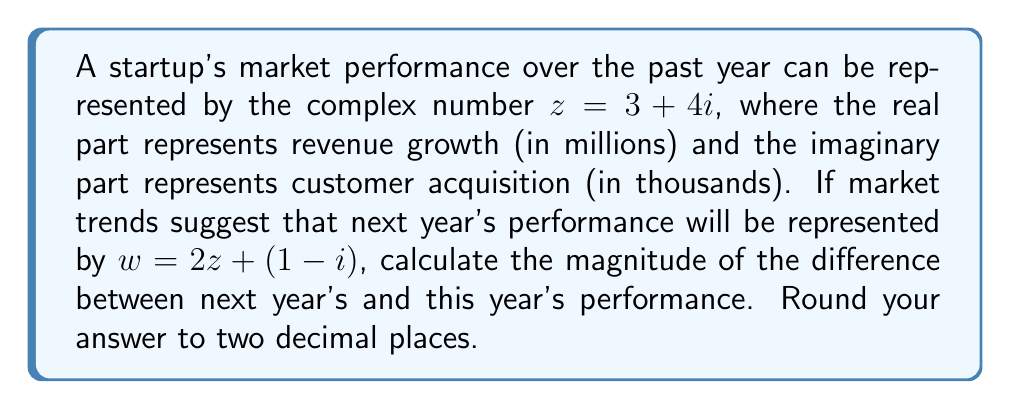Could you help me with this problem? Let's approach this step-by-step:

1) First, we need to calculate $w$:
   $w = 2z + (1-i)$
   $w = 2(3+4i) + (1-i)$
   $w = 6 + 8i + 1 - i$
   $w = 7 + 7i$

2) Now, we need to find the difference between $w$ and $z$:
   $w - z = (7 + 7i) - (3 + 4i)$
   $w - z = 4 + 3i$

3) To find the magnitude of this difference, we use the formula:
   $|a + bi| = \sqrt{a^2 + b^2}$

4) Plugging in our values:
   $|4 + 3i| = \sqrt{4^2 + 3^2}$
   $|4 + 3i| = \sqrt{16 + 9}$
   $|4 + 3i| = \sqrt{25}$
   $|4 + 3i| = 5$

5) The question asks for the answer rounded to two decimal places, so our final answer is 5.00.

This result represents the overall change in performance from this year to next year, combining both revenue growth and customer acquisition into a single metric.
Answer: 5.00 